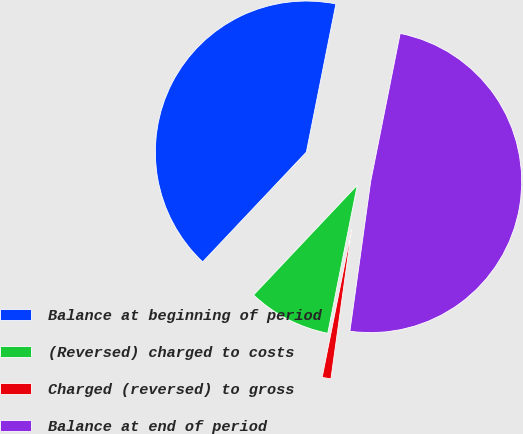<chart> <loc_0><loc_0><loc_500><loc_500><pie_chart><fcel>Balance at beginning of period<fcel>(Reversed) charged to costs<fcel>Charged (reversed) to gross<fcel>Balance at end of period<nl><fcel>41.09%<fcel>8.91%<fcel>0.94%<fcel>49.06%<nl></chart> 